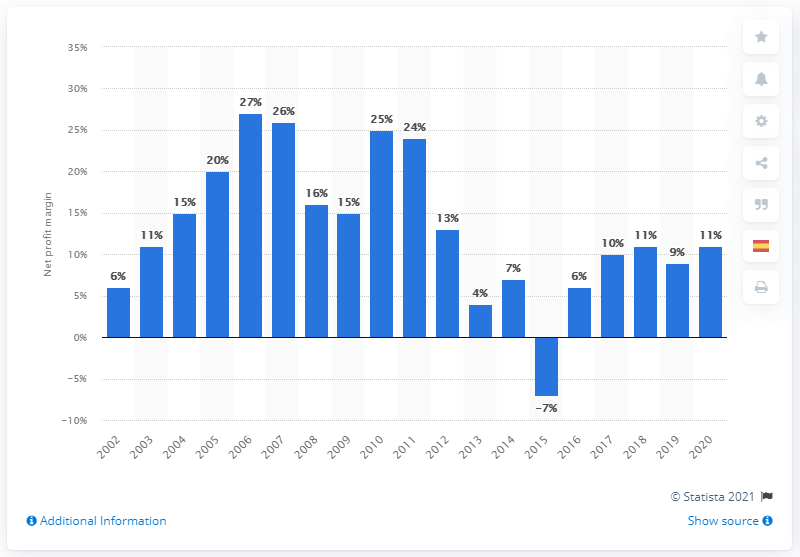Point out several critical features in this image. In 2011, the net profit margin of the mining industry's 40 leading companies was 24%. The net profit margin of the mining industry's 40 leading companies in 2020 was 11%. 